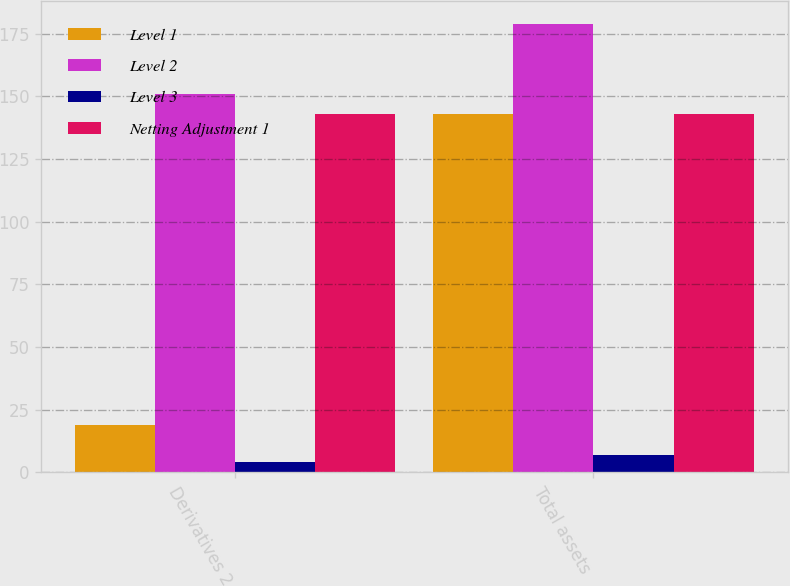Convert chart. <chart><loc_0><loc_0><loc_500><loc_500><stacked_bar_chart><ecel><fcel>Derivatives 2<fcel>Total assets<nl><fcel>Level 1<fcel>19<fcel>143<nl><fcel>Level 2<fcel>151<fcel>179<nl><fcel>Level 3<fcel>4<fcel>7<nl><fcel>Netting Adjustment 1<fcel>143<fcel>143<nl></chart> 